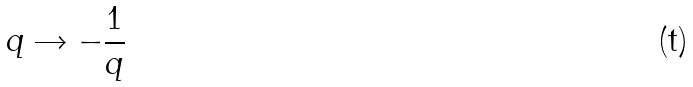Convert formula to latex. <formula><loc_0><loc_0><loc_500><loc_500>q \rightarrow - \frac { 1 } { q }</formula> 